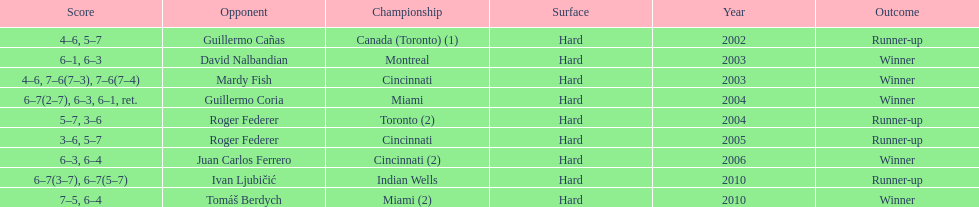How many championships occurred in toronto or montreal? 3. 